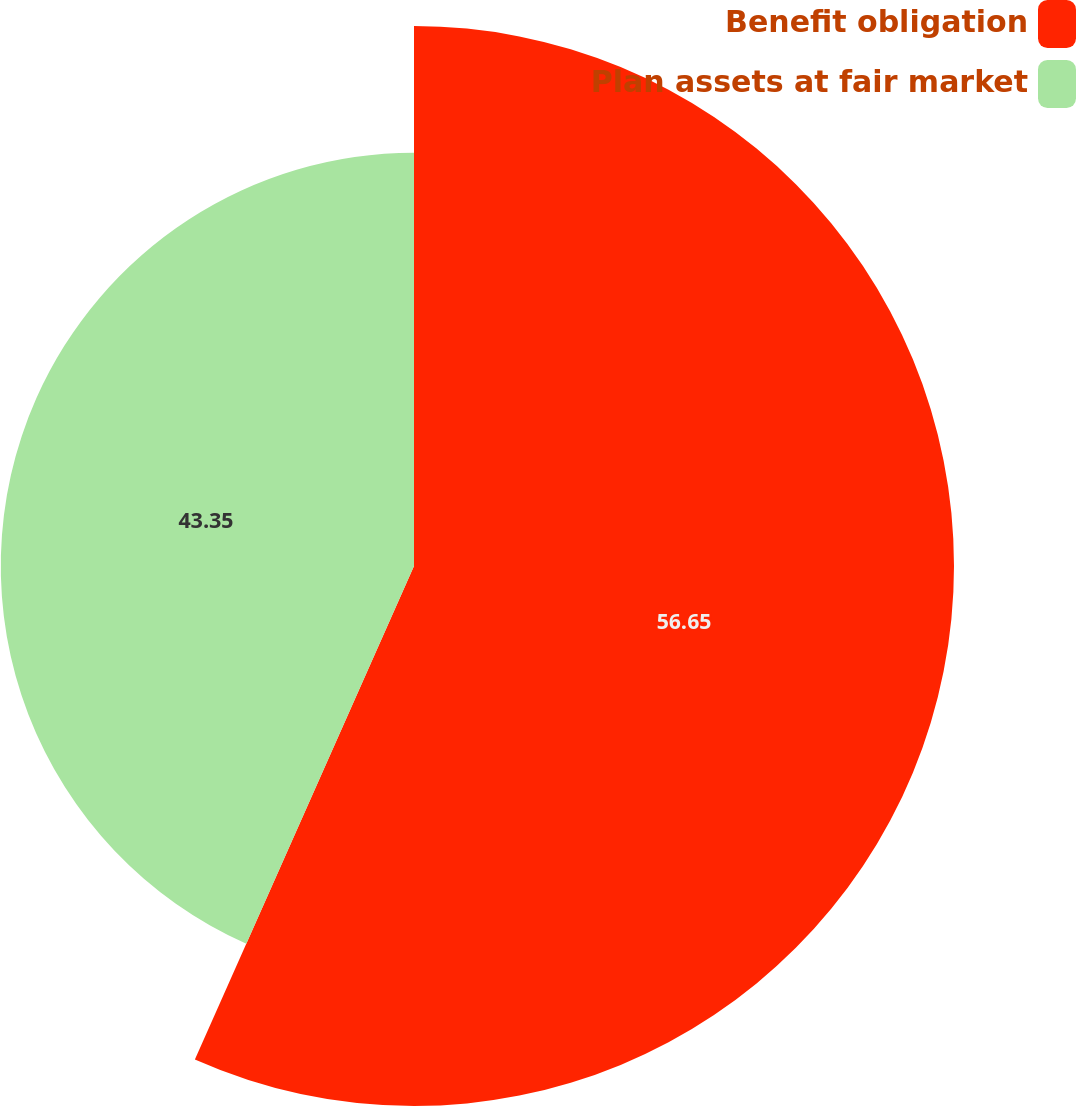Convert chart. <chart><loc_0><loc_0><loc_500><loc_500><pie_chart><fcel>Benefit obligation<fcel>Plan assets at fair market<nl><fcel>56.65%<fcel>43.35%<nl></chart> 